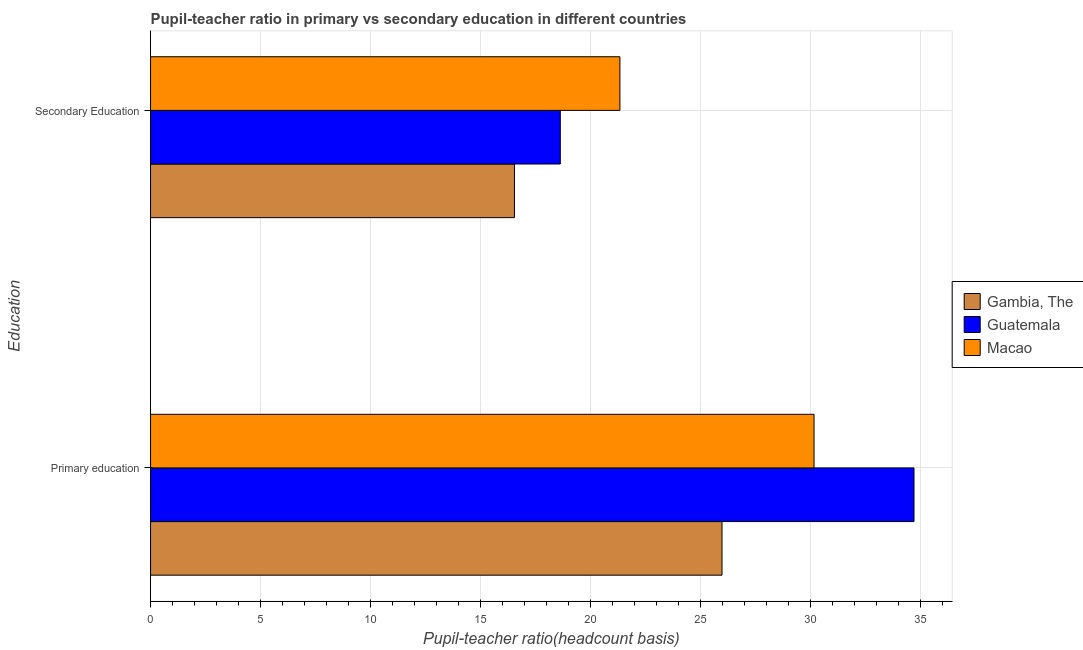How many groups of bars are there?
Your answer should be very brief. 2. Are the number of bars on each tick of the Y-axis equal?
Offer a very short reply. Yes. What is the pupil-teacher ratio in primary education in Guatemala?
Ensure brevity in your answer.  34.69. Across all countries, what is the maximum pupil-teacher ratio in primary education?
Your response must be concise. 34.69. Across all countries, what is the minimum pupil-teacher ratio in primary education?
Provide a succinct answer. 25.96. In which country was the pupil teacher ratio on secondary education maximum?
Provide a short and direct response. Macao. In which country was the pupil-teacher ratio in primary education minimum?
Your response must be concise. Gambia, The. What is the total pupil teacher ratio on secondary education in the graph?
Offer a very short reply. 56.47. What is the difference between the pupil teacher ratio on secondary education in Gambia, The and that in Macao?
Make the answer very short. -4.79. What is the difference between the pupil teacher ratio on secondary education in Gambia, The and the pupil-teacher ratio in primary education in Guatemala?
Your response must be concise. -18.15. What is the average pupil-teacher ratio in primary education per country?
Provide a short and direct response. 30.26. What is the difference between the pupil teacher ratio on secondary education and pupil-teacher ratio in primary education in Guatemala?
Give a very brief answer. -16.07. What is the ratio of the pupil-teacher ratio in primary education in Macao to that in Guatemala?
Ensure brevity in your answer.  0.87. What does the 3rd bar from the top in Secondary Education represents?
Offer a terse response. Gambia, The. What does the 1st bar from the bottom in Primary education represents?
Keep it short and to the point. Gambia, The. What is the difference between two consecutive major ticks on the X-axis?
Make the answer very short. 5. Where does the legend appear in the graph?
Ensure brevity in your answer.  Center right. How many legend labels are there?
Give a very brief answer. 3. How are the legend labels stacked?
Your answer should be compact. Vertical. What is the title of the graph?
Keep it short and to the point. Pupil-teacher ratio in primary vs secondary education in different countries. What is the label or title of the X-axis?
Your answer should be compact. Pupil-teacher ratio(headcount basis). What is the label or title of the Y-axis?
Your response must be concise. Education. What is the Pupil-teacher ratio(headcount basis) of Gambia, The in Primary education?
Give a very brief answer. 25.96. What is the Pupil-teacher ratio(headcount basis) in Guatemala in Primary education?
Keep it short and to the point. 34.69. What is the Pupil-teacher ratio(headcount basis) in Macao in Primary education?
Keep it short and to the point. 30.14. What is the Pupil-teacher ratio(headcount basis) of Gambia, The in Secondary Education?
Make the answer very short. 16.53. What is the Pupil-teacher ratio(headcount basis) of Guatemala in Secondary Education?
Offer a terse response. 18.62. What is the Pupil-teacher ratio(headcount basis) in Macao in Secondary Education?
Give a very brief answer. 21.32. Across all Education, what is the maximum Pupil-teacher ratio(headcount basis) in Gambia, The?
Offer a terse response. 25.96. Across all Education, what is the maximum Pupil-teacher ratio(headcount basis) of Guatemala?
Give a very brief answer. 34.69. Across all Education, what is the maximum Pupil-teacher ratio(headcount basis) of Macao?
Offer a very short reply. 30.14. Across all Education, what is the minimum Pupil-teacher ratio(headcount basis) in Gambia, The?
Offer a terse response. 16.53. Across all Education, what is the minimum Pupil-teacher ratio(headcount basis) in Guatemala?
Your answer should be very brief. 18.62. Across all Education, what is the minimum Pupil-teacher ratio(headcount basis) of Macao?
Give a very brief answer. 21.32. What is the total Pupil-teacher ratio(headcount basis) in Gambia, The in the graph?
Ensure brevity in your answer.  42.5. What is the total Pupil-teacher ratio(headcount basis) of Guatemala in the graph?
Your answer should be very brief. 53.3. What is the total Pupil-teacher ratio(headcount basis) in Macao in the graph?
Offer a terse response. 51.47. What is the difference between the Pupil-teacher ratio(headcount basis) in Gambia, The in Primary education and that in Secondary Education?
Make the answer very short. 9.43. What is the difference between the Pupil-teacher ratio(headcount basis) of Guatemala in Primary education and that in Secondary Education?
Keep it short and to the point. 16.07. What is the difference between the Pupil-teacher ratio(headcount basis) of Macao in Primary education and that in Secondary Education?
Offer a very short reply. 8.82. What is the difference between the Pupil-teacher ratio(headcount basis) in Gambia, The in Primary education and the Pupil-teacher ratio(headcount basis) in Guatemala in Secondary Education?
Your answer should be very brief. 7.35. What is the difference between the Pupil-teacher ratio(headcount basis) of Gambia, The in Primary education and the Pupil-teacher ratio(headcount basis) of Macao in Secondary Education?
Ensure brevity in your answer.  4.64. What is the difference between the Pupil-teacher ratio(headcount basis) of Guatemala in Primary education and the Pupil-teacher ratio(headcount basis) of Macao in Secondary Education?
Offer a very short reply. 13.36. What is the average Pupil-teacher ratio(headcount basis) in Gambia, The per Education?
Keep it short and to the point. 21.25. What is the average Pupil-teacher ratio(headcount basis) in Guatemala per Education?
Provide a succinct answer. 26.65. What is the average Pupil-teacher ratio(headcount basis) in Macao per Education?
Give a very brief answer. 25.73. What is the difference between the Pupil-teacher ratio(headcount basis) of Gambia, The and Pupil-teacher ratio(headcount basis) of Guatemala in Primary education?
Your answer should be very brief. -8.72. What is the difference between the Pupil-teacher ratio(headcount basis) in Gambia, The and Pupil-teacher ratio(headcount basis) in Macao in Primary education?
Your response must be concise. -4.18. What is the difference between the Pupil-teacher ratio(headcount basis) of Guatemala and Pupil-teacher ratio(headcount basis) of Macao in Primary education?
Offer a very short reply. 4.54. What is the difference between the Pupil-teacher ratio(headcount basis) in Gambia, The and Pupil-teacher ratio(headcount basis) in Guatemala in Secondary Education?
Give a very brief answer. -2.08. What is the difference between the Pupil-teacher ratio(headcount basis) of Gambia, The and Pupil-teacher ratio(headcount basis) of Macao in Secondary Education?
Your response must be concise. -4.79. What is the difference between the Pupil-teacher ratio(headcount basis) of Guatemala and Pupil-teacher ratio(headcount basis) of Macao in Secondary Education?
Your answer should be compact. -2.71. What is the ratio of the Pupil-teacher ratio(headcount basis) of Gambia, The in Primary education to that in Secondary Education?
Offer a very short reply. 1.57. What is the ratio of the Pupil-teacher ratio(headcount basis) of Guatemala in Primary education to that in Secondary Education?
Provide a succinct answer. 1.86. What is the ratio of the Pupil-teacher ratio(headcount basis) in Macao in Primary education to that in Secondary Education?
Your answer should be very brief. 1.41. What is the difference between the highest and the second highest Pupil-teacher ratio(headcount basis) in Gambia, The?
Make the answer very short. 9.43. What is the difference between the highest and the second highest Pupil-teacher ratio(headcount basis) of Guatemala?
Your answer should be compact. 16.07. What is the difference between the highest and the second highest Pupil-teacher ratio(headcount basis) in Macao?
Ensure brevity in your answer.  8.82. What is the difference between the highest and the lowest Pupil-teacher ratio(headcount basis) of Gambia, The?
Make the answer very short. 9.43. What is the difference between the highest and the lowest Pupil-teacher ratio(headcount basis) of Guatemala?
Offer a terse response. 16.07. What is the difference between the highest and the lowest Pupil-teacher ratio(headcount basis) in Macao?
Provide a short and direct response. 8.82. 